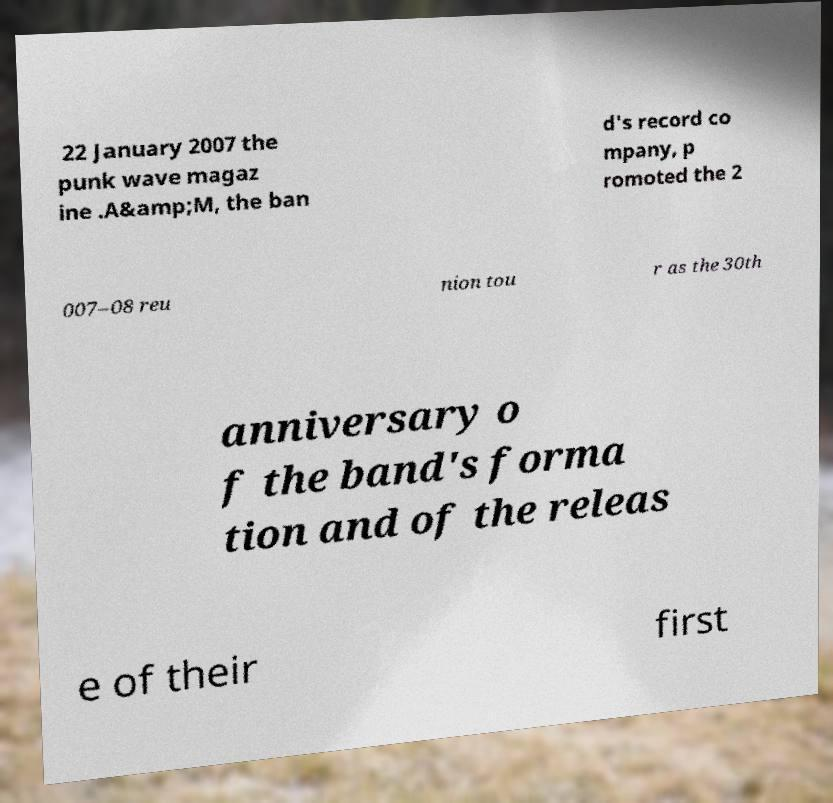There's text embedded in this image that I need extracted. Can you transcribe it verbatim? 22 January 2007 the punk wave magaz ine .A&amp;M, the ban d's record co mpany, p romoted the 2 007–08 reu nion tou r as the 30th anniversary o f the band's forma tion and of the releas e of their first 